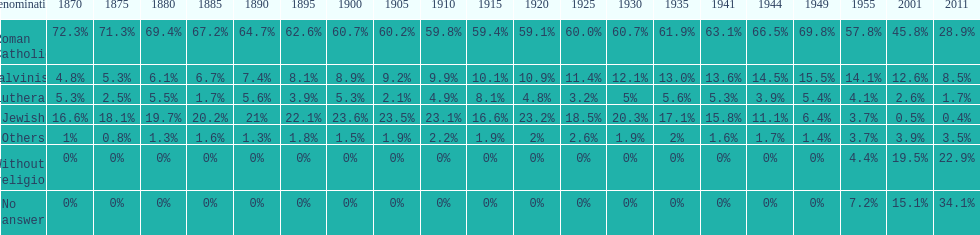Which religious denomination had a higher percentage in 1900, jewish or roman catholic? Roman Catholic. 